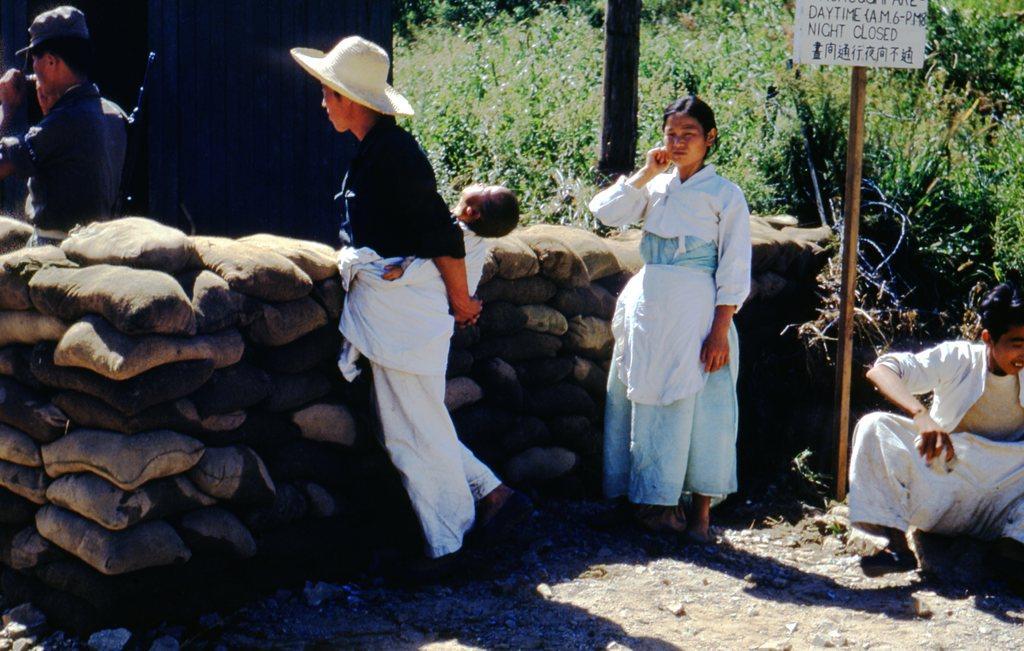Can you describe this image briefly? In this image we can see one small house, some objects on the surface, some stones, one soldier carrying a gun and holding one object. One person sitting and holding one object. Two women are standing and one woman with cap, carrying a baby. There are some plants, bushes and grass. 